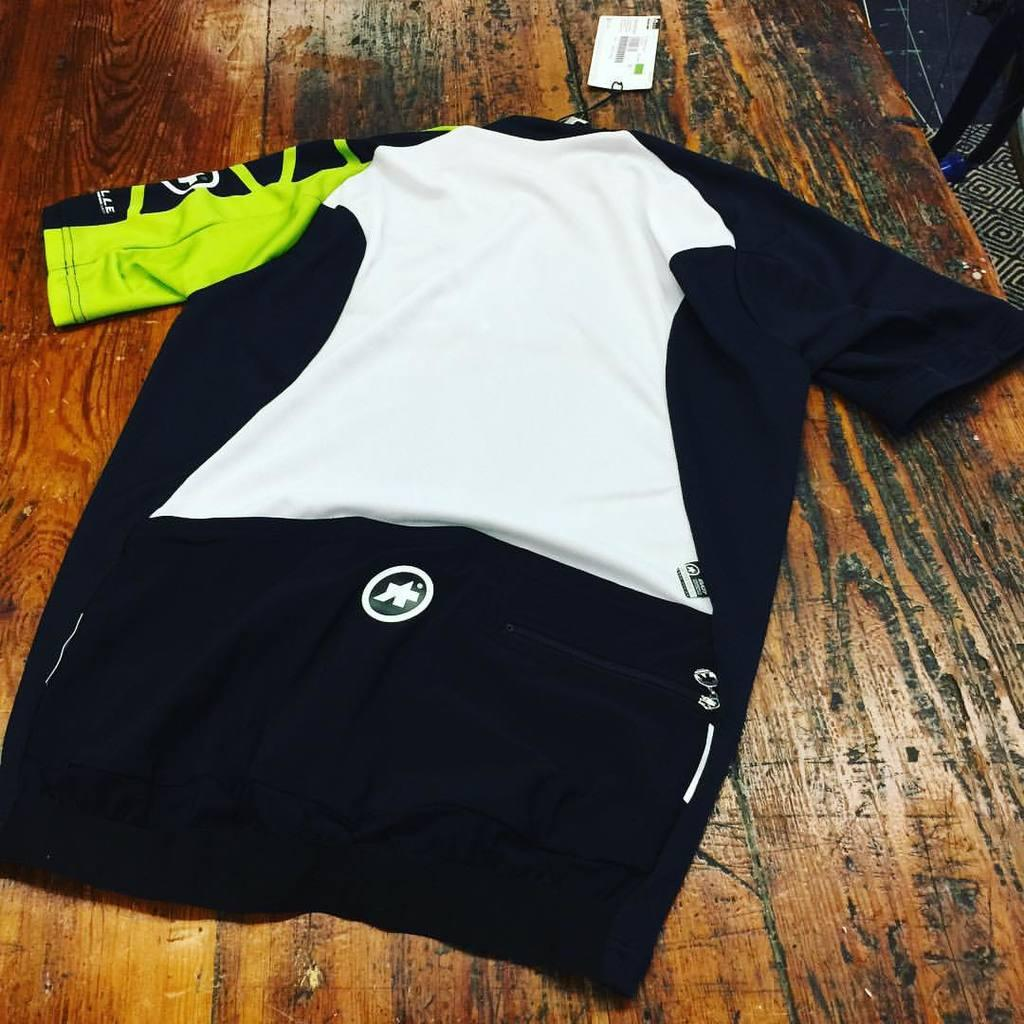What type of clothing item is visible in the image? There is a t-shirt in the image. Is there any additional information about the t-shirt? Yes, the t-shirt has a price tag. Where is the t-shirt and price tag located? The t-shirt and price tag are placed on a table. Reasoning: Let'g: Let's think step by step in order to produce the conversation. We start by identifying the main subject in the image, which is the t-shirt. Then, we expand the conversation to include the price tag, which is another important detail mentioned in the facts. Finally, we describe the location of the t-shirt and price tag, which is on a table. Each question is designed to elicit a specific detail about the image that is known from the provided facts. Absurd Question/Answer: What historical event is depicted on the desk in the image? There is no desk present in the image, and no historical event is depicted. 